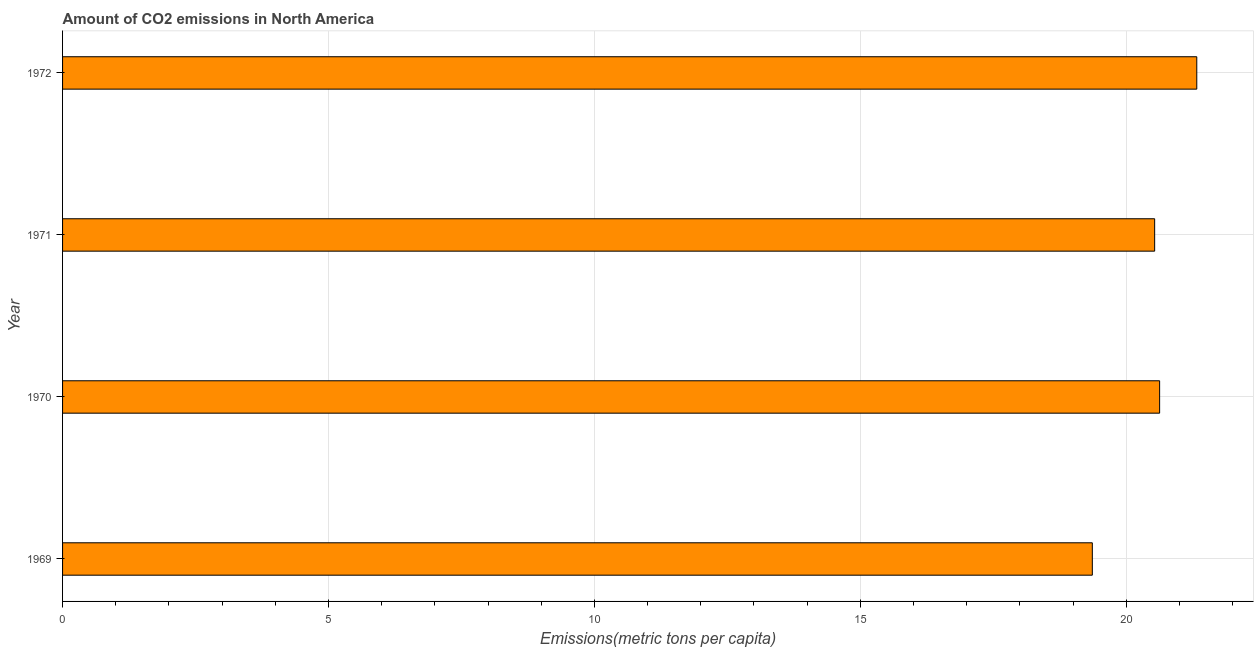Does the graph contain any zero values?
Your answer should be very brief. No. Does the graph contain grids?
Offer a terse response. Yes. What is the title of the graph?
Give a very brief answer. Amount of CO2 emissions in North America. What is the label or title of the X-axis?
Provide a short and direct response. Emissions(metric tons per capita). What is the label or title of the Y-axis?
Ensure brevity in your answer.  Year. What is the amount of co2 emissions in 1971?
Provide a short and direct response. 20.53. Across all years, what is the maximum amount of co2 emissions?
Provide a succinct answer. 21.33. Across all years, what is the minimum amount of co2 emissions?
Your response must be concise. 19.36. In which year was the amount of co2 emissions minimum?
Make the answer very short. 1969. What is the sum of the amount of co2 emissions?
Make the answer very short. 81.85. What is the difference between the amount of co2 emissions in 1971 and 1972?
Offer a very short reply. -0.79. What is the average amount of co2 emissions per year?
Make the answer very short. 20.46. What is the median amount of co2 emissions?
Your answer should be very brief. 20.58. What is the ratio of the amount of co2 emissions in 1970 to that in 1972?
Your answer should be very brief. 0.97. Is the difference between the amount of co2 emissions in 1969 and 1971 greater than the difference between any two years?
Your answer should be compact. No. What is the difference between the highest and the second highest amount of co2 emissions?
Make the answer very short. 0.7. Is the sum of the amount of co2 emissions in 1971 and 1972 greater than the maximum amount of co2 emissions across all years?
Make the answer very short. Yes. What is the difference between the highest and the lowest amount of co2 emissions?
Make the answer very short. 1.96. How many years are there in the graph?
Offer a terse response. 4. What is the difference between two consecutive major ticks on the X-axis?
Your response must be concise. 5. Are the values on the major ticks of X-axis written in scientific E-notation?
Give a very brief answer. No. What is the Emissions(metric tons per capita) of 1969?
Your response must be concise. 19.36. What is the Emissions(metric tons per capita) in 1970?
Keep it short and to the point. 20.63. What is the Emissions(metric tons per capita) of 1971?
Provide a succinct answer. 20.53. What is the Emissions(metric tons per capita) of 1972?
Your response must be concise. 21.33. What is the difference between the Emissions(metric tons per capita) in 1969 and 1970?
Keep it short and to the point. -1.27. What is the difference between the Emissions(metric tons per capita) in 1969 and 1971?
Provide a short and direct response. -1.17. What is the difference between the Emissions(metric tons per capita) in 1969 and 1972?
Ensure brevity in your answer.  -1.96. What is the difference between the Emissions(metric tons per capita) in 1970 and 1971?
Your response must be concise. 0.09. What is the difference between the Emissions(metric tons per capita) in 1970 and 1972?
Make the answer very short. -0.7. What is the difference between the Emissions(metric tons per capita) in 1971 and 1972?
Keep it short and to the point. -0.79. What is the ratio of the Emissions(metric tons per capita) in 1969 to that in 1970?
Ensure brevity in your answer.  0.94. What is the ratio of the Emissions(metric tons per capita) in 1969 to that in 1971?
Provide a succinct answer. 0.94. What is the ratio of the Emissions(metric tons per capita) in 1969 to that in 1972?
Give a very brief answer. 0.91. What is the ratio of the Emissions(metric tons per capita) in 1970 to that in 1972?
Your answer should be very brief. 0.97. What is the ratio of the Emissions(metric tons per capita) in 1971 to that in 1972?
Your response must be concise. 0.96. 